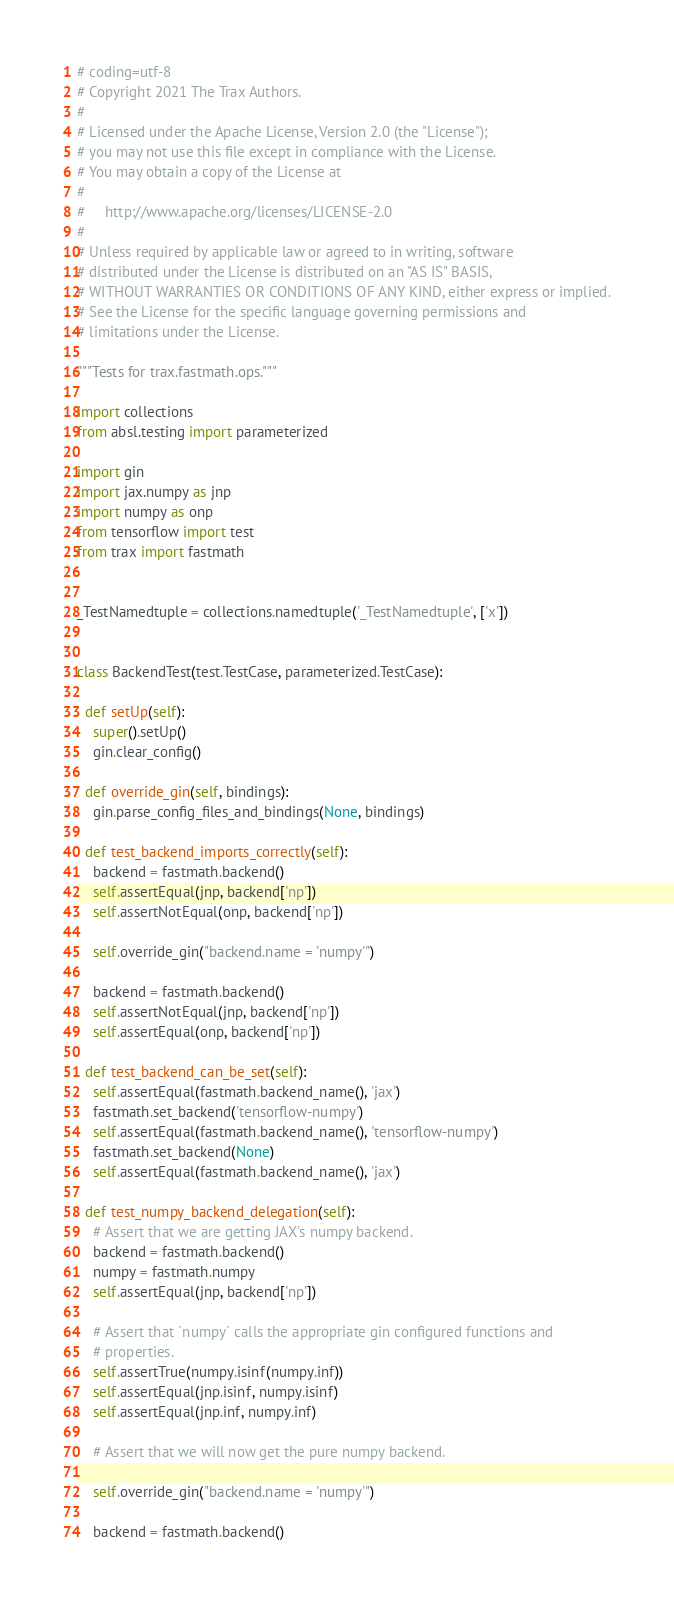<code> <loc_0><loc_0><loc_500><loc_500><_Python_># coding=utf-8
# Copyright 2021 The Trax Authors.
#
# Licensed under the Apache License, Version 2.0 (the "License");
# you may not use this file except in compliance with the License.
# You may obtain a copy of the License at
#
#     http://www.apache.org/licenses/LICENSE-2.0
#
# Unless required by applicable law or agreed to in writing, software
# distributed under the License is distributed on an "AS IS" BASIS,
# WITHOUT WARRANTIES OR CONDITIONS OF ANY KIND, either express or implied.
# See the License for the specific language governing permissions and
# limitations under the License.

"""Tests for trax.fastmath.ops."""

import collections
from absl.testing import parameterized

import gin
import jax.numpy as jnp
import numpy as onp
from tensorflow import test
from trax import fastmath


_TestNamedtuple = collections.namedtuple('_TestNamedtuple', ['x'])


class BackendTest(test.TestCase, parameterized.TestCase):

  def setUp(self):
    super().setUp()
    gin.clear_config()

  def override_gin(self, bindings):
    gin.parse_config_files_and_bindings(None, bindings)

  def test_backend_imports_correctly(self):
    backend = fastmath.backend()
    self.assertEqual(jnp, backend['np'])
    self.assertNotEqual(onp, backend['np'])

    self.override_gin("backend.name = 'numpy'")

    backend = fastmath.backend()
    self.assertNotEqual(jnp, backend['np'])
    self.assertEqual(onp, backend['np'])

  def test_backend_can_be_set(self):
    self.assertEqual(fastmath.backend_name(), 'jax')
    fastmath.set_backend('tensorflow-numpy')
    self.assertEqual(fastmath.backend_name(), 'tensorflow-numpy')
    fastmath.set_backend(None)
    self.assertEqual(fastmath.backend_name(), 'jax')

  def test_numpy_backend_delegation(self):
    # Assert that we are getting JAX's numpy backend.
    backend = fastmath.backend()
    numpy = fastmath.numpy
    self.assertEqual(jnp, backend['np'])

    # Assert that `numpy` calls the appropriate gin configured functions and
    # properties.
    self.assertTrue(numpy.isinf(numpy.inf))
    self.assertEqual(jnp.isinf, numpy.isinf)
    self.assertEqual(jnp.inf, numpy.inf)

    # Assert that we will now get the pure numpy backend.

    self.override_gin("backend.name = 'numpy'")

    backend = fastmath.backend()</code> 